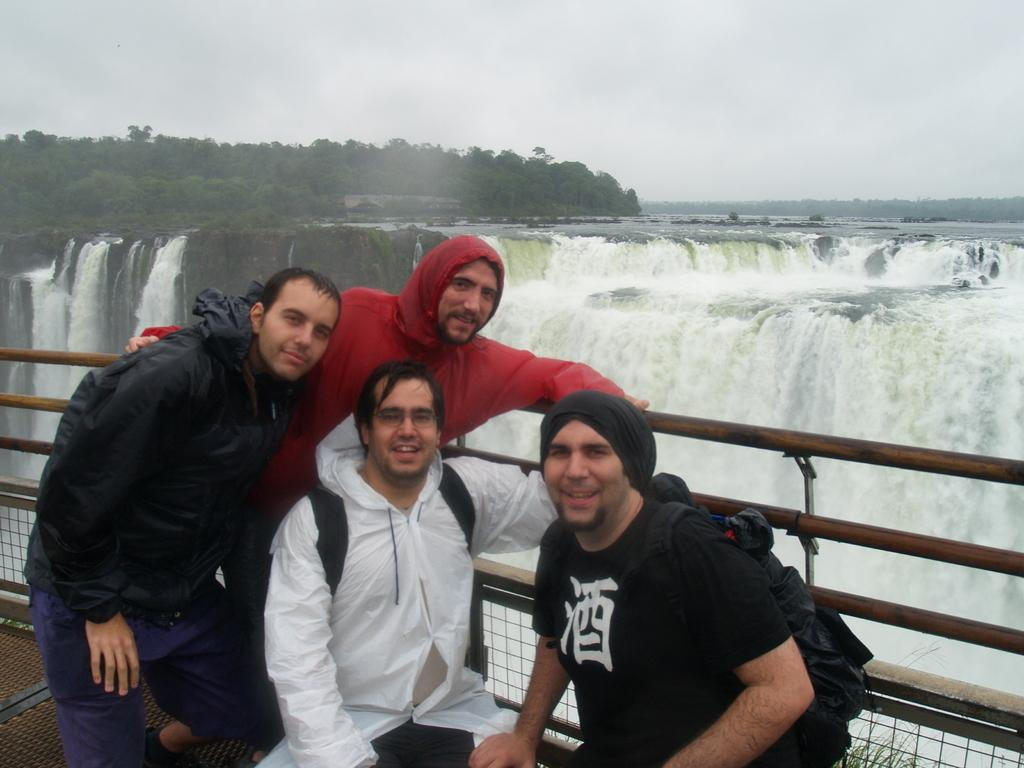What is located in the center of the image? There are men, a boundary, and a waterfall in the center of the image. Can you describe the men in the image? The men are in the center of the image, but their specific actions or appearances are not mentioned in the provided facts. What type of boundary is present in the image? The facts only mention that there is a boundary in the center of the image, without specifying its nature or material. What natural feature can be seen in the image? There is a waterfall in the center of the image. How many ducks are sitting on the country in the image? There is no mention of a country or ducks in the image, so this question cannot be answered. 